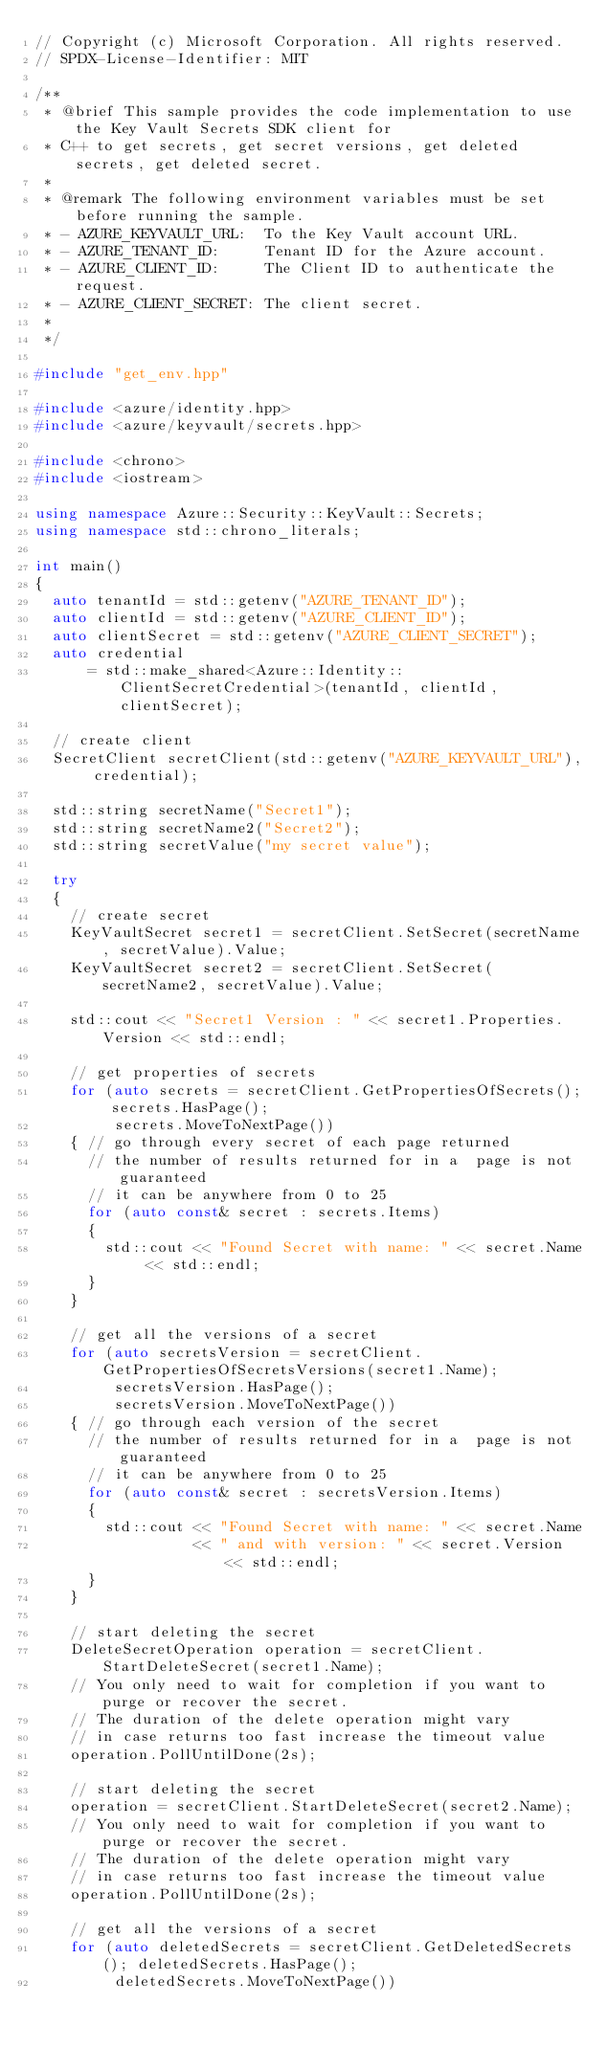<code> <loc_0><loc_0><loc_500><loc_500><_C++_>// Copyright (c) Microsoft Corporation. All rights reserved.
// SPDX-License-Identifier: MIT

/**
 * @brief This sample provides the code implementation to use the Key Vault Secrets SDK client for
 * C++ to get secrets, get secret versions, get deleted secrets, get deleted secret.
 *
 * @remark The following environment variables must be set before running the sample.
 * - AZURE_KEYVAULT_URL:  To the Key Vault account URL.
 * - AZURE_TENANT_ID:     Tenant ID for the Azure account.
 * - AZURE_CLIENT_ID:     The Client ID to authenticate the request.
 * - AZURE_CLIENT_SECRET: The client secret.
 *
 */

#include "get_env.hpp"

#include <azure/identity.hpp>
#include <azure/keyvault/secrets.hpp>

#include <chrono>
#include <iostream>

using namespace Azure::Security::KeyVault::Secrets;
using namespace std::chrono_literals;

int main()
{
  auto tenantId = std::getenv("AZURE_TENANT_ID");
  auto clientId = std::getenv("AZURE_CLIENT_ID");
  auto clientSecret = std::getenv("AZURE_CLIENT_SECRET");
  auto credential
      = std::make_shared<Azure::Identity::ClientSecretCredential>(tenantId, clientId, clientSecret);

  // create client
  SecretClient secretClient(std::getenv("AZURE_KEYVAULT_URL"), credential);

  std::string secretName("Secret1");
  std::string secretName2("Secret2");
  std::string secretValue("my secret value");

  try
  {
    // create secret
    KeyVaultSecret secret1 = secretClient.SetSecret(secretName, secretValue).Value;
    KeyVaultSecret secret2 = secretClient.SetSecret(secretName2, secretValue).Value;

    std::cout << "Secret1 Version : " << secret1.Properties.Version << std::endl;

    // get properties of secrets
    for (auto secrets = secretClient.GetPropertiesOfSecrets(); secrets.HasPage();
         secrets.MoveToNextPage())
    { // go through every secret of each page returned
      // the number of results returned for in a  page is not guaranteed
      // it can be anywhere from 0 to 25
      for (auto const& secret : secrets.Items)
      {
        std::cout << "Found Secret with name: " << secret.Name << std::endl;
      }
    }

    // get all the versions of a secret
    for (auto secretsVersion = secretClient.GetPropertiesOfSecretsVersions(secret1.Name);
         secretsVersion.HasPage();
         secretsVersion.MoveToNextPage())
    { // go through each version of the secret
      // the number of results returned for in a  page is not guaranteed
      // it can be anywhere from 0 to 25
      for (auto const& secret : secretsVersion.Items)
      {
        std::cout << "Found Secret with name: " << secret.Name
                  << " and with version: " << secret.Version << std::endl;
      }
    }

    // start deleting the secret
    DeleteSecretOperation operation = secretClient.StartDeleteSecret(secret1.Name);
    // You only need to wait for completion if you want to purge or recover the secret.
    // The duration of the delete operation might vary
    // in case returns too fast increase the timeout value
    operation.PollUntilDone(2s);

    // start deleting the secret
    operation = secretClient.StartDeleteSecret(secret2.Name);
    // You only need to wait for completion if you want to purge or recover the secret.
    // The duration of the delete operation might vary
    // in case returns too fast increase the timeout value
    operation.PollUntilDone(2s);

    // get all the versions of a secret
    for (auto deletedSecrets = secretClient.GetDeletedSecrets(); deletedSecrets.HasPage();
         deletedSecrets.MoveToNextPage())</code> 